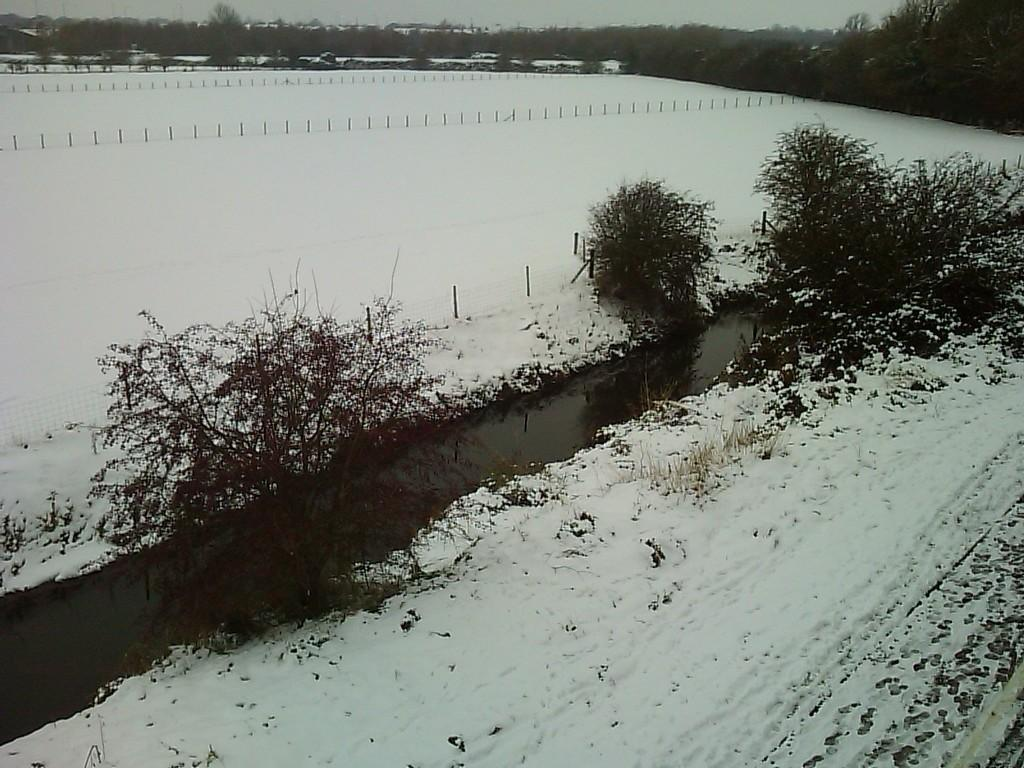What type of vegetation can be seen in the image? There are trees in the image. What is the weather like in the image? There is snow in the image, which suggests a cold or wintery environment. Can you see a crib in the image? There is no crib present in the image. How many crows are visible in the image? There are no crows present in the image. 